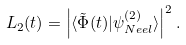<formula> <loc_0><loc_0><loc_500><loc_500>L _ { 2 } ( t ) = \left | \langle \tilde { \Phi } ( t ) | \psi _ { N e e l } ^ { ( 2 ) } \rangle \right | ^ { 2 } .</formula> 